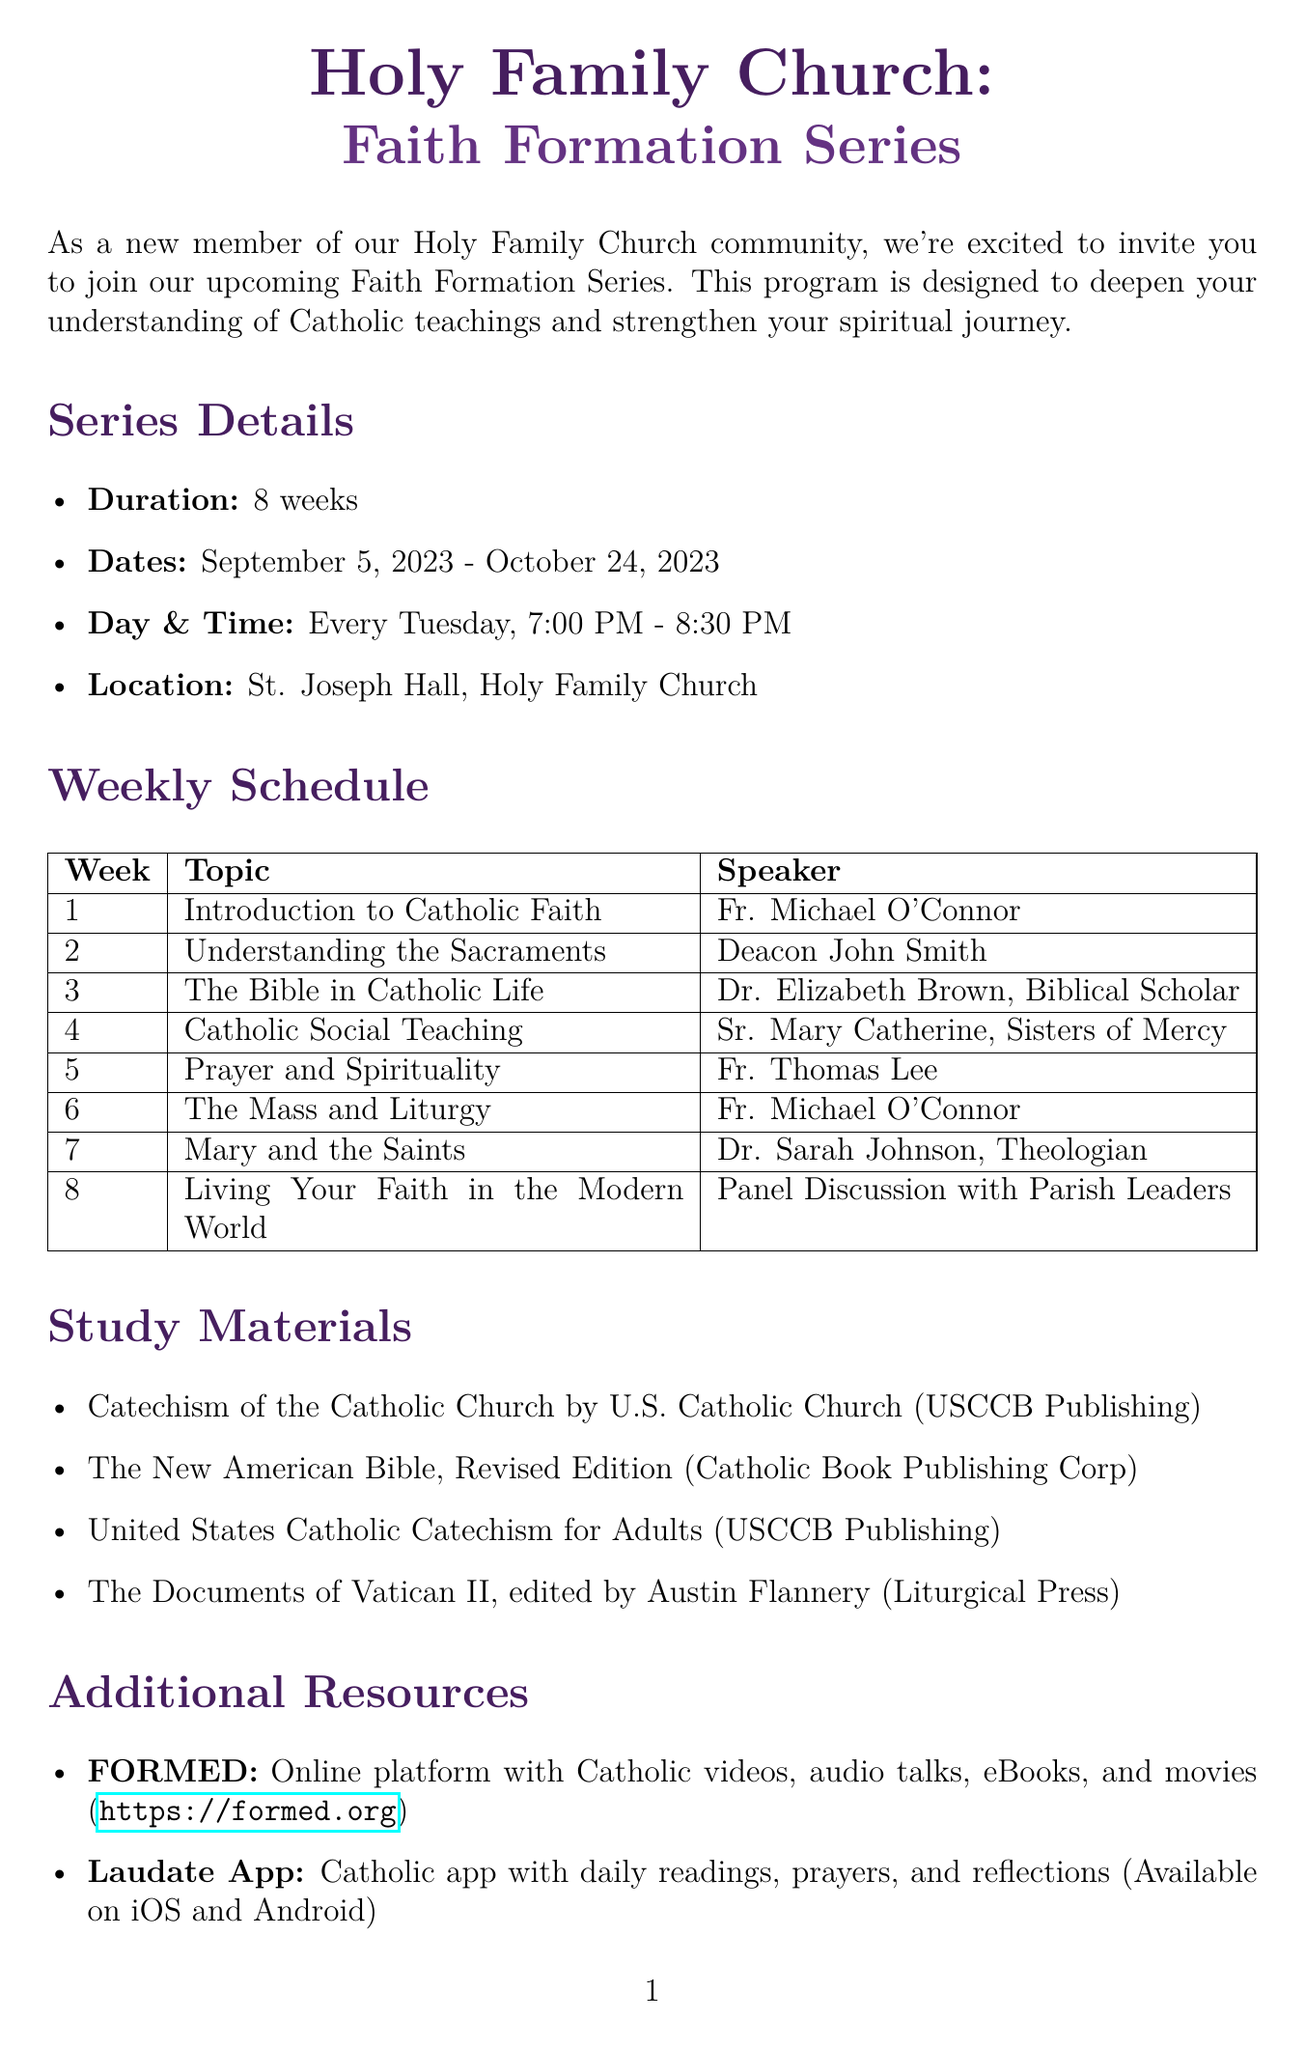What is the duration of the Faith Formation Series? The duration is specified as 8 weeks in the document.
Answer: 8 weeks When does the Faith Formation Series start? The start date of the series is indicated in the document as September 5, 2023.
Answer: September 5, 2023 Who is the speaker for week 5? The document states that Fr. Thomas Lee is the speaker for week 5.
Answer: Fr. Thomas Lee What is the registration deadline? The document mentions that the registration deadline is August 29, 2023.
Answer: August 29, 2023 What is the location of the series? The document specifies that the series will take place in St. Joseph Hall, Holy Family Church.
Answer: St. Joseph Hall, Holy Family Church How many study materials are listed? The document enumerates four study materials available for the series.
Answer: 4 Who can be contacted for more information? Mrs. Angela Martinez is named as the contact person for inquiries in the document.
Answer: Mrs. Angela Martinez What is the topic for week 4? The document lists "Catholic Social Teaching" as the topic for week 4.
Answer: Catholic Social Teaching What is the website for the additional resource FORM? The document provides the website for FORM as https://formed.org.
Answer: https://formed.org 